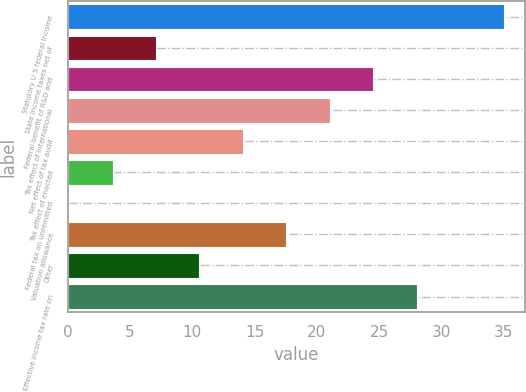Convert chart to OTSL. <chart><loc_0><loc_0><loc_500><loc_500><bar_chart><fcel>Statutory U S federal income<fcel>State income taxes net of<fcel>Federal benefit of R&D and<fcel>Tax effect of international<fcel>Net effect of tax audit<fcel>Tax effect of enacted<fcel>Federal tax on unremitted<fcel>Valuation allowance<fcel>Other<fcel>Effective income tax rate on<nl><fcel>35<fcel>7.08<fcel>24.53<fcel>21.04<fcel>14.06<fcel>3.59<fcel>0.1<fcel>17.55<fcel>10.57<fcel>28.02<nl></chart> 